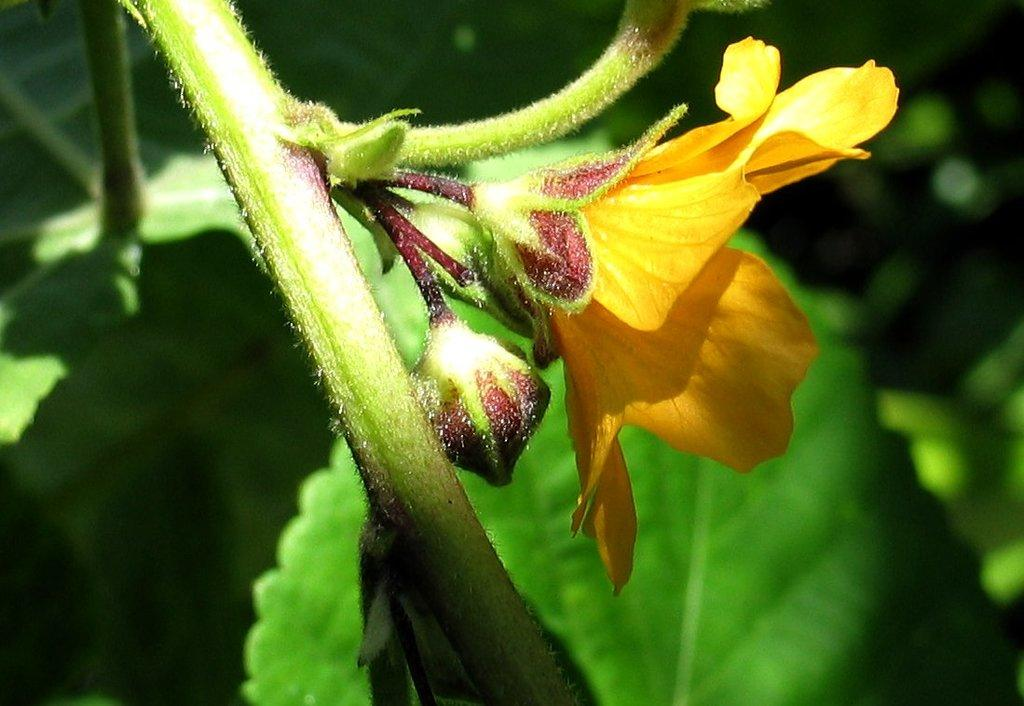What is the main subject in the middle of the image? There is a stem in the image, and flowers are on the stem. Can you describe the flowers on the stem? The flowers on the stem are visible in the image. Where is the stem and flowers located in the image? The stem and flowers are in the middle of the image. What type of whip is being used to water the flowers in the image? There is no whip present in the image, and the flowers are not being watered. 